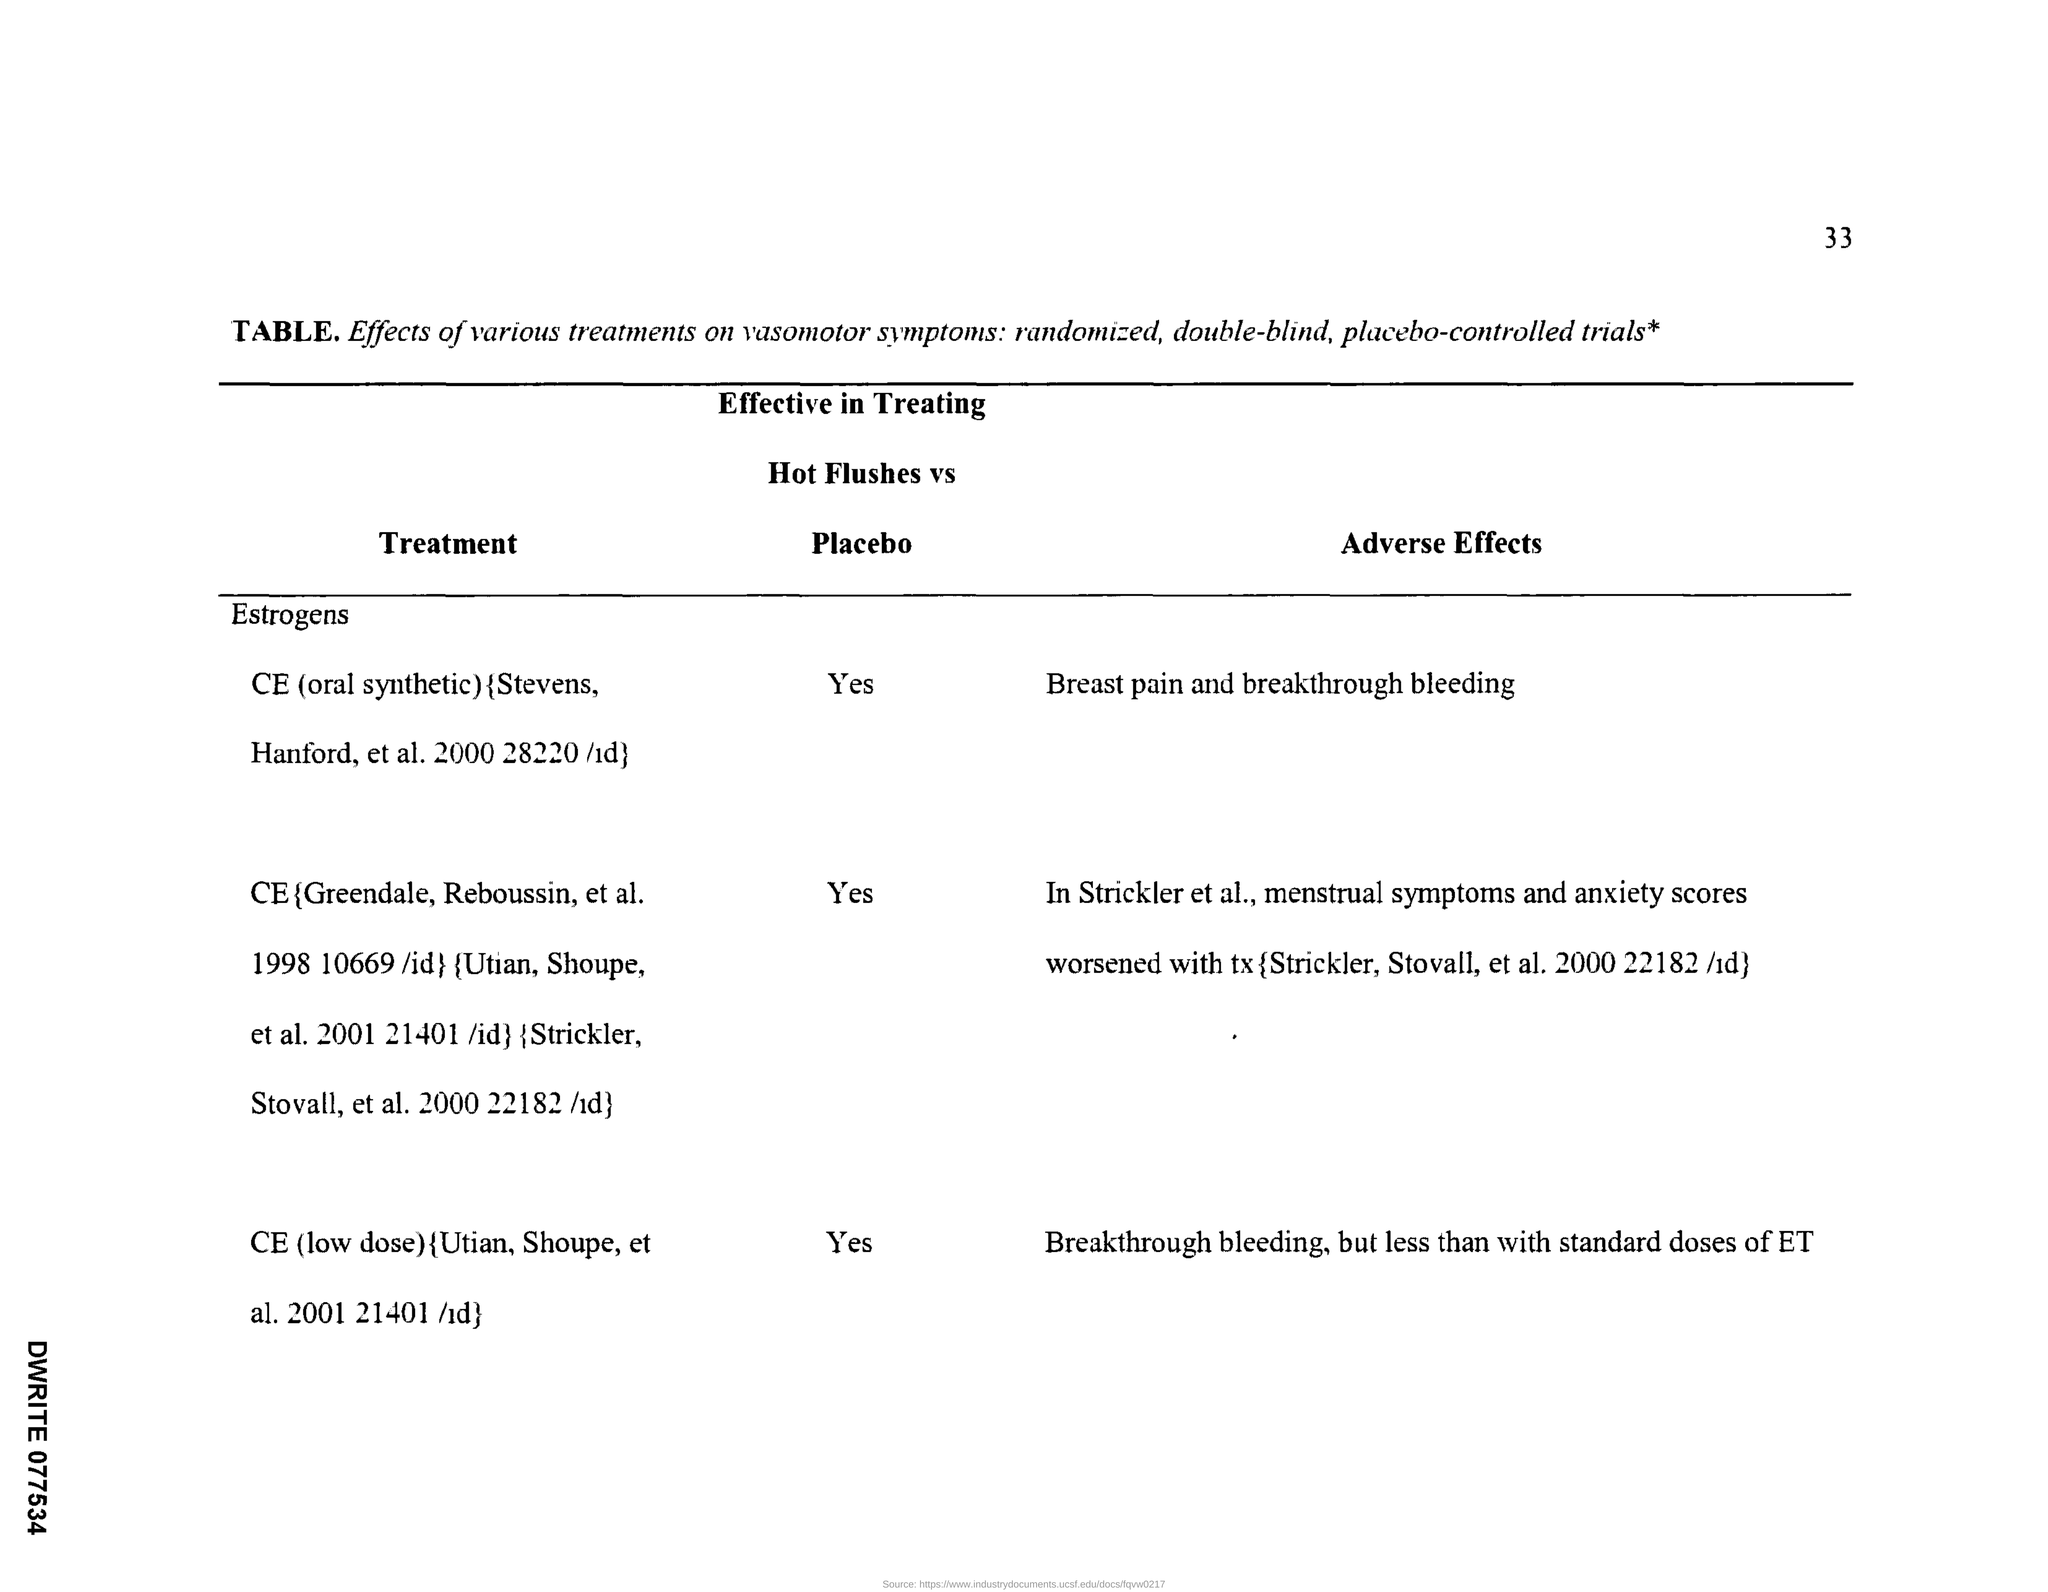Give some essential details in this illustration. The use of estrogen with or without progestins for hormone therapy has been shown to be effective in reducing the frequency and severity of hot flashes in menopausal women. Specifically, a study found that CE (a type of estrogen) at a low dose was effective in treating hot flashes compared to a placebo. This suggests that hormone therapy may be an effective treatment option for menopausal women experiencing hot flashes. The use of oral synthetic CE is effective in treating hot flushes compared to placebo, according to research. 